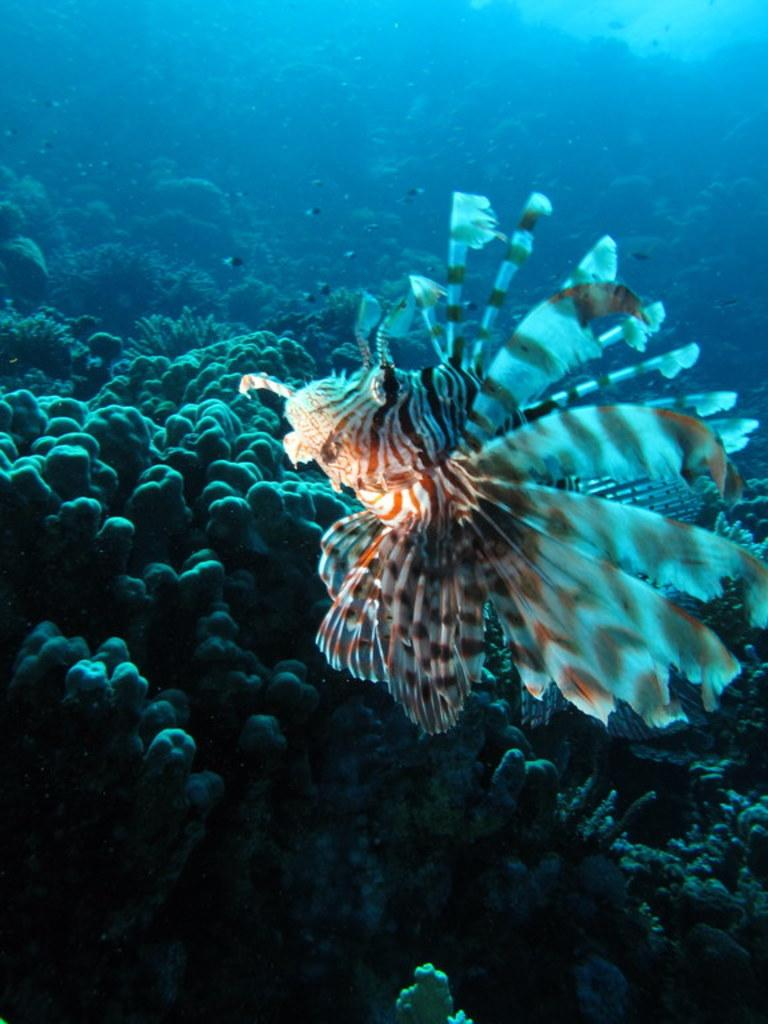What is in the water in the image? There is a fish in the water in the image. What can be seen in the background of the image? There are plants in the background of the image. Are the plants above or below the water? The plants are underwater in the image. What color is the background of the image? The background color is blue. What type of dress is hanging in the bedroom in the image? There is no bedroom or dress present in the image; it features a fish in water with underwater plants and a blue background. 